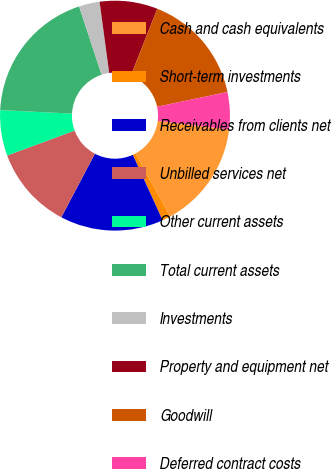Convert chart. <chart><loc_0><loc_0><loc_500><loc_500><pie_chart><fcel>Cash and cash equivalents<fcel>Short-term investments<fcel>Receivables from clients net<fcel>Unbilled services net<fcel>Other current assets<fcel>Total current assets<fcel>Investments<fcel>Property and equipment net<fcel>Goodwill<fcel>Deferred contract costs<nl><fcel>15.12%<fcel>1.16%<fcel>14.53%<fcel>11.63%<fcel>6.4%<fcel>19.19%<fcel>2.91%<fcel>8.14%<fcel>15.7%<fcel>5.23%<nl></chart> 